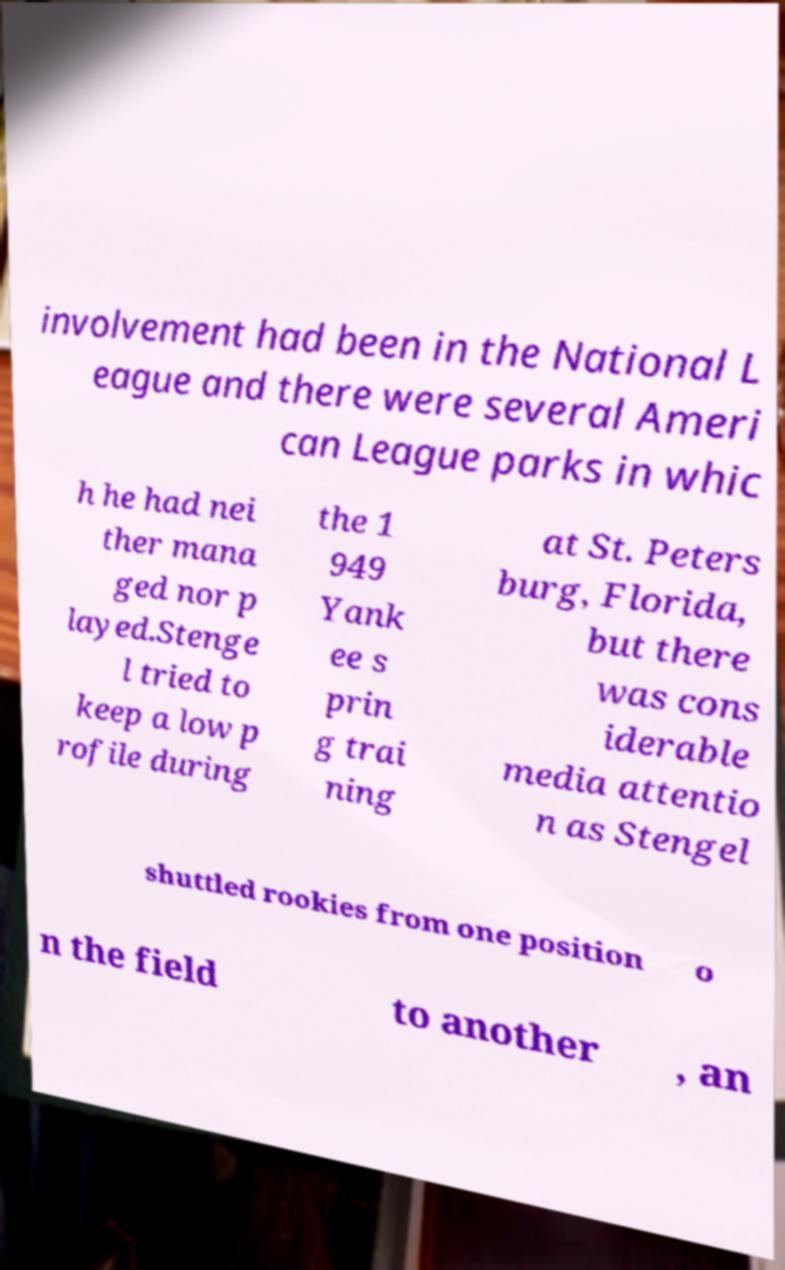Could you assist in decoding the text presented in this image and type it out clearly? involvement had been in the National L eague and there were several Ameri can League parks in whic h he had nei ther mana ged nor p layed.Stenge l tried to keep a low p rofile during the 1 949 Yank ee s prin g trai ning at St. Peters burg, Florida, but there was cons iderable media attentio n as Stengel shuttled rookies from one position o n the field to another , an 